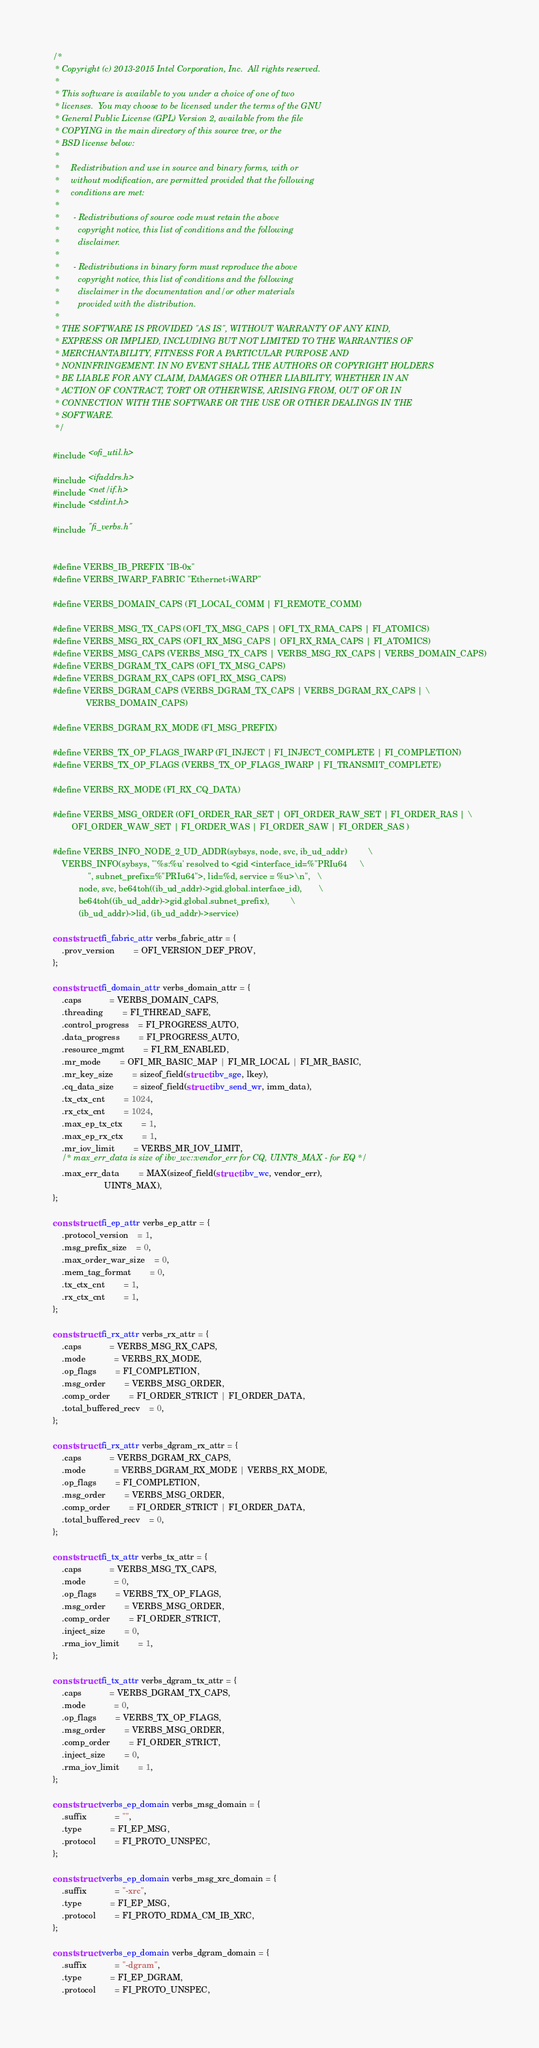Convert code to text. <code><loc_0><loc_0><loc_500><loc_500><_C_>/*
 * Copyright (c) 2013-2015 Intel Corporation, Inc.  All rights reserved.
 *
 * This software is available to you under a choice of one of two
 * licenses.  You may choose to be licensed under the terms of the GNU
 * General Public License (GPL) Version 2, available from the file
 * COPYING in the main directory of this source tree, or the
 * BSD license below:
 *
 *     Redistribution and use in source and binary forms, with or
 *     without modification, are permitted provided that the following
 *     conditions are met:
 *
 *      - Redistributions of source code must retain the above
 *        copyright notice, this list of conditions and the following
 *        disclaimer.
 *
 *      - Redistributions in binary form must reproduce the above
 *        copyright notice, this list of conditions and the following
 *        disclaimer in the documentation and/or other materials
 *        provided with the distribution.
 *
 * THE SOFTWARE IS PROVIDED "AS IS", WITHOUT WARRANTY OF ANY KIND,
 * EXPRESS OR IMPLIED, INCLUDING BUT NOT LIMITED TO THE WARRANTIES OF
 * MERCHANTABILITY, FITNESS FOR A PARTICULAR PURPOSE AND
 * NONINFRINGEMENT. IN NO EVENT SHALL THE AUTHORS OR COPYRIGHT HOLDERS
 * BE LIABLE FOR ANY CLAIM, DAMAGES OR OTHER LIABILITY, WHETHER IN AN
 * ACTION OF CONTRACT, TORT OR OTHERWISE, ARISING FROM, OUT OF OR IN
 * CONNECTION WITH THE SOFTWARE OR THE USE OR OTHER DEALINGS IN THE
 * SOFTWARE.
 */

#include <ofi_util.h>

#include <ifaddrs.h>
#include <net/if.h>
#include <stdint.h>

#include "fi_verbs.h"


#define VERBS_IB_PREFIX "IB-0x"
#define VERBS_IWARP_FABRIC "Ethernet-iWARP"

#define VERBS_DOMAIN_CAPS (FI_LOCAL_COMM | FI_REMOTE_COMM)

#define VERBS_MSG_TX_CAPS (OFI_TX_MSG_CAPS | OFI_TX_RMA_CAPS | FI_ATOMICS)
#define VERBS_MSG_RX_CAPS (OFI_RX_MSG_CAPS | OFI_RX_RMA_CAPS | FI_ATOMICS)
#define VERBS_MSG_CAPS (VERBS_MSG_TX_CAPS | VERBS_MSG_RX_CAPS | VERBS_DOMAIN_CAPS)
#define VERBS_DGRAM_TX_CAPS (OFI_TX_MSG_CAPS)
#define VERBS_DGRAM_RX_CAPS (OFI_RX_MSG_CAPS)
#define VERBS_DGRAM_CAPS (VERBS_DGRAM_TX_CAPS | VERBS_DGRAM_RX_CAPS | \
			  VERBS_DOMAIN_CAPS)

#define VERBS_DGRAM_RX_MODE (FI_MSG_PREFIX)

#define VERBS_TX_OP_FLAGS_IWARP (FI_INJECT | FI_INJECT_COMPLETE | FI_COMPLETION)
#define VERBS_TX_OP_FLAGS (VERBS_TX_OP_FLAGS_IWARP | FI_TRANSMIT_COMPLETE)

#define VERBS_RX_MODE (FI_RX_CQ_DATA)

#define VERBS_MSG_ORDER (OFI_ORDER_RAR_SET | OFI_ORDER_RAW_SET | FI_ORDER_RAS | \
		OFI_ORDER_WAW_SET | FI_ORDER_WAS | FI_ORDER_SAW | FI_ORDER_SAS )

#define VERBS_INFO_NODE_2_UD_ADDR(sybsys, node, svc, ib_ud_addr)			\
	VERBS_INFO(sybsys, "'%s:%u' resolved to <gid <interface_id=%"PRIu64		\
			   ", subnet_prefix=%"PRIu64">, lid=%d, service = %u>\n",	\
		   node, svc, be64toh((ib_ud_addr)->gid.global.interface_id),		\
		   be64toh((ib_ud_addr)->gid.global.subnet_prefix),			\
		   (ib_ud_addr)->lid, (ib_ud_addr)->service)

const struct fi_fabric_attr verbs_fabric_attr = {
	.prov_version		= OFI_VERSION_DEF_PROV,
};

const struct fi_domain_attr verbs_domain_attr = {
	.caps			= VERBS_DOMAIN_CAPS,
	.threading		= FI_THREAD_SAFE,
	.control_progress	= FI_PROGRESS_AUTO,
	.data_progress		= FI_PROGRESS_AUTO,
	.resource_mgmt		= FI_RM_ENABLED,
	.mr_mode		= OFI_MR_BASIC_MAP | FI_MR_LOCAL | FI_MR_BASIC,
	.mr_key_size		= sizeof_field(struct ibv_sge, lkey),
	.cq_data_size		= sizeof_field(struct ibv_send_wr, imm_data),
	.tx_ctx_cnt		= 1024,
	.rx_ctx_cnt		= 1024,
	.max_ep_tx_ctx		= 1,
	.max_ep_rx_ctx		= 1,
	.mr_iov_limit		= VERBS_MR_IOV_LIMIT,
	/* max_err_data is size of ibv_wc::vendor_err for CQ, UINT8_MAX - for EQ */
	.max_err_data		= MAX(sizeof_field(struct ibv_wc, vendor_err),
				      UINT8_MAX),
};

const struct fi_ep_attr verbs_ep_attr = {
	.protocol_version	= 1,
	.msg_prefix_size	= 0,
	.max_order_war_size	= 0,
	.mem_tag_format		= 0,
	.tx_ctx_cnt		= 1,
	.rx_ctx_cnt		= 1,
};

const struct fi_rx_attr verbs_rx_attr = {
	.caps			= VERBS_MSG_RX_CAPS,
	.mode			= VERBS_RX_MODE,
	.op_flags		= FI_COMPLETION,
	.msg_order		= VERBS_MSG_ORDER,
	.comp_order		= FI_ORDER_STRICT | FI_ORDER_DATA,
	.total_buffered_recv	= 0,
};

const struct fi_rx_attr verbs_dgram_rx_attr = {
	.caps			= VERBS_DGRAM_RX_CAPS,
	.mode			= VERBS_DGRAM_RX_MODE | VERBS_RX_MODE,
	.op_flags		= FI_COMPLETION,
	.msg_order		= VERBS_MSG_ORDER,
	.comp_order		= FI_ORDER_STRICT | FI_ORDER_DATA,
	.total_buffered_recv	= 0,
};

const struct fi_tx_attr verbs_tx_attr = {
	.caps			= VERBS_MSG_TX_CAPS,
	.mode			= 0,
	.op_flags		= VERBS_TX_OP_FLAGS,
	.msg_order		= VERBS_MSG_ORDER,
	.comp_order		= FI_ORDER_STRICT,
	.inject_size		= 0,
	.rma_iov_limit		= 1,
};

const struct fi_tx_attr verbs_dgram_tx_attr = {
	.caps			= VERBS_DGRAM_TX_CAPS,
	.mode			= 0,
	.op_flags		= VERBS_TX_OP_FLAGS,
	.msg_order		= VERBS_MSG_ORDER,
	.comp_order		= FI_ORDER_STRICT,
	.inject_size		= 0,
	.rma_iov_limit		= 1,
};

const struct verbs_ep_domain verbs_msg_domain = {
	.suffix			= "",
	.type			= FI_EP_MSG,
	.protocol		= FI_PROTO_UNSPEC,
};

const struct verbs_ep_domain verbs_msg_xrc_domain = {
	.suffix			= "-xrc",
	.type			= FI_EP_MSG,
	.protocol		= FI_PROTO_RDMA_CM_IB_XRC,
};

const struct verbs_ep_domain verbs_dgram_domain = {
	.suffix			= "-dgram",
	.type			= FI_EP_DGRAM,
	.protocol		= FI_PROTO_UNSPEC,</code> 